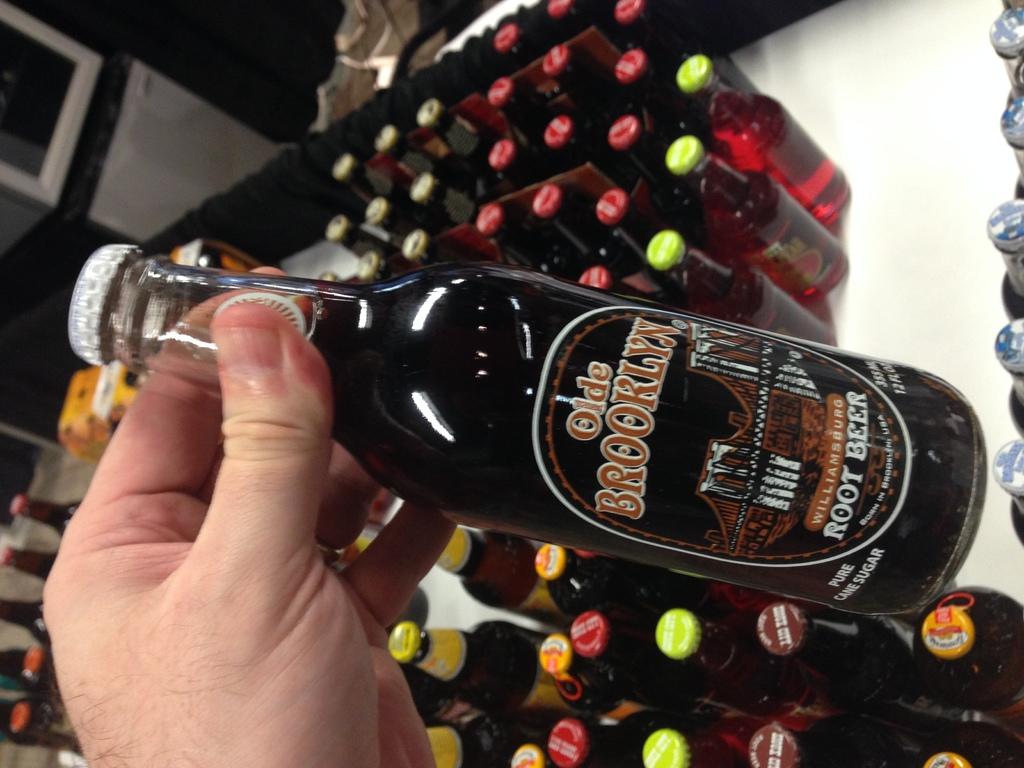What brand of alcohol is on display?
Your answer should be very brief. Olde brooklyn. Is there more than one beer on the floor?
Make the answer very short. Yes. 